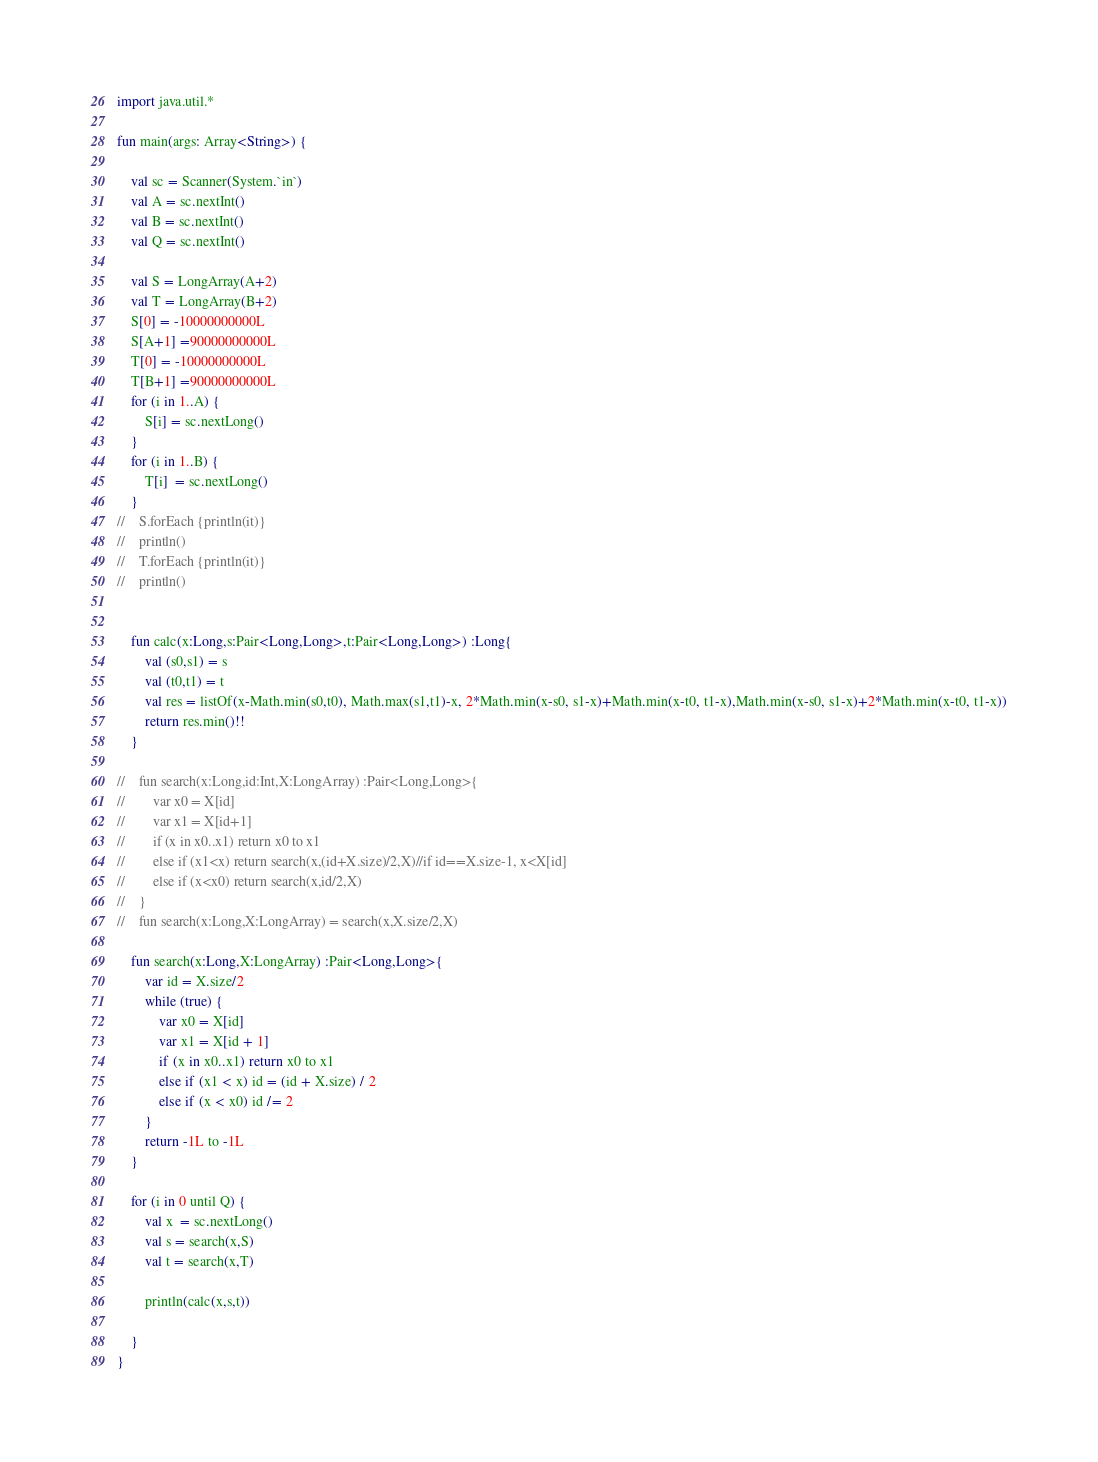Convert code to text. <code><loc_0><loc_0><loc_500><loc_500><_Kotlin_>import java.util.*

fun main(args: Array<String>) {

    val sc = Scanner(System.`in`)
    val A = sc.nextInt()
    val B = sc.nextInt()
    val Q = sc.nextInt()

    val S = LongArray(A+2)
    val T = LongArray(B+2)
    S[0] = -10000000000L
    S[A+1] =90000000000L
    T[0] = -10000000000L
    T[B+1] =90000000000L
    for (i in 1..A) {
        S[i] = sc.nextLong()
    }
    for (i in 1..B) {
        T[i]  = sc.nextLong()
    }
//    S.forEach {println(it)}
//    println()
//    T.forEach {println(it)}
//    println()


    fun calc(x:Long,s:Pair<Long,Long>,t:Pair<Long,Long>) :Long{
        val (s0,s1) = s
        val (t0,t1) = t
        val res = listOf(x-Math.min(s0,t0), Math.max(s1,t1)-x, 2*Math.min(x-s0, s1-x)+Math.min(x-t0, t1-x),Math.min(x-s0, s1-x)+2*Math.min(x-t0, t1-x))
        return res.min()!!
    }

//    fun search(x:Long,id:Int,X:LongArray) :Pair<Long,Long>{
//        var x0 = X[id]
//        var x1 = X[id+1]
//        if (x in x0..x1) return x0 to x1
//        else if (x1<x) return search(x,(id+X.size)/2,X)//if id==X.size-1, x<X[id]
//        else if (x<x0) return search(x,id/2,X)
//    }
//    fun search(x:Long,X:LongArray) = search(x,X.size/2,X)
    
    fun search(x:Long,X:LongArray) :Pair<Long,Long>{
        var id = X.size/2
        while (true) {
            var x0 = X[id]
            var x1 = X[id + 1]
            if (x in x0..x1) return x0 to x1
            else if (x1 < x) id = (id + X.size) / 2
            else if (x < x0) id /= 2
        }
        return -1L to -1L
    }
    
    for (i in 0 until Q) {
        val x  = sc.nextLong()
        val s = search(x,S)
        val t = search(x,T)
        
        println(calc(x,s,t))

    }
}
</code> 